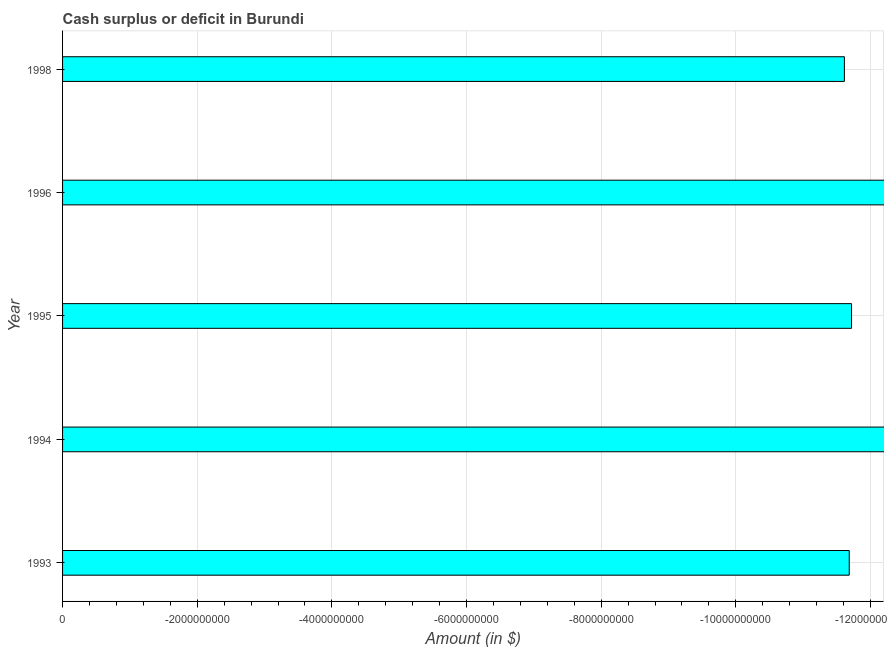What is the title of the graph?
Keep it short and to the point. Cash surplus or deficit in Burundi. What is the label or title of the X-axis?
Your response must be concise. Amount (in $). What is the cash surplus or deficit in 1998?
Ensure brevity in your answer.  0. Across all years, what is the minimum cash surplus or deficit?
Give a very brief answer. 0. What is the sum of the cash surplus or deficit?
Provide a short and direct response. 0. What is the median cash surplus or deficit?
Ensure brevity in your answer.  0. In how many years, is the cash surplus or deficit greater than the average cash surplus or deficit taken over all years?
Offer a terse response. 0. What is the difference between two consecutive major ticks on the X-axis?
Keep it short and to the point. 2.00e+09. What is the Amount (in $) of 1993?
Your response must be concise. 0. What is the Amount (in $) in 1998?
Offer a very short reply. 0. 